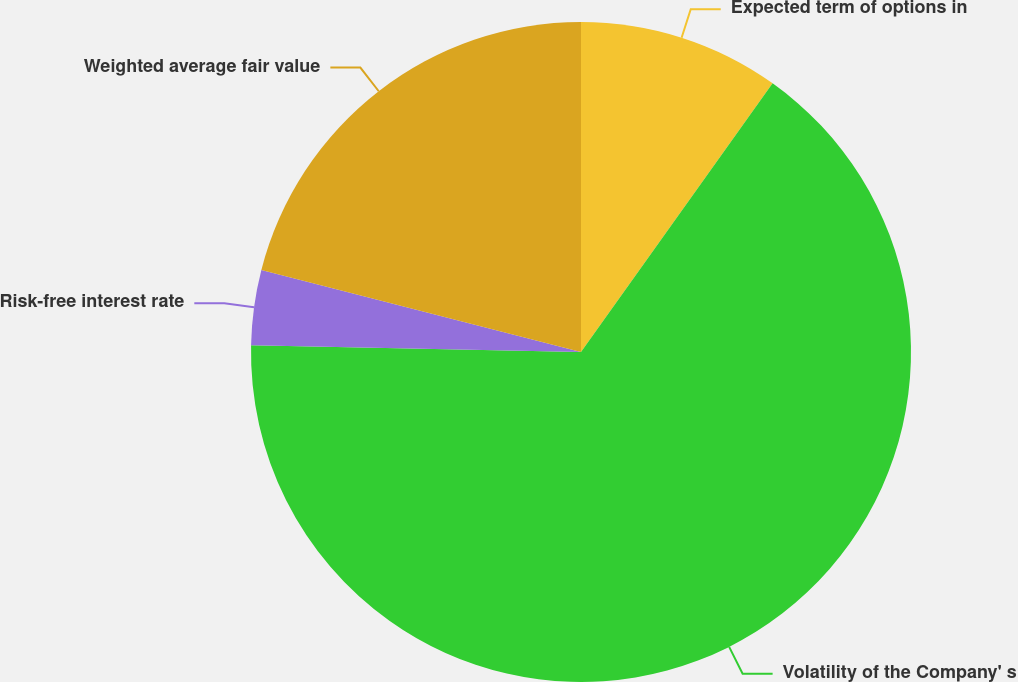Convert chart to OTSL. <chart><loc_0><loc_0><loc_500><loc_500><pie_chart><fcel>Expected term of options in<fcel>Volatility of the Company' s<fcel>Risk-free interest rate<fcel>Weighted average fair value<nl><fcel>9.86%<fcel>65.46%<fcel>3.68%<fcel>21.0%<nl></chart> 